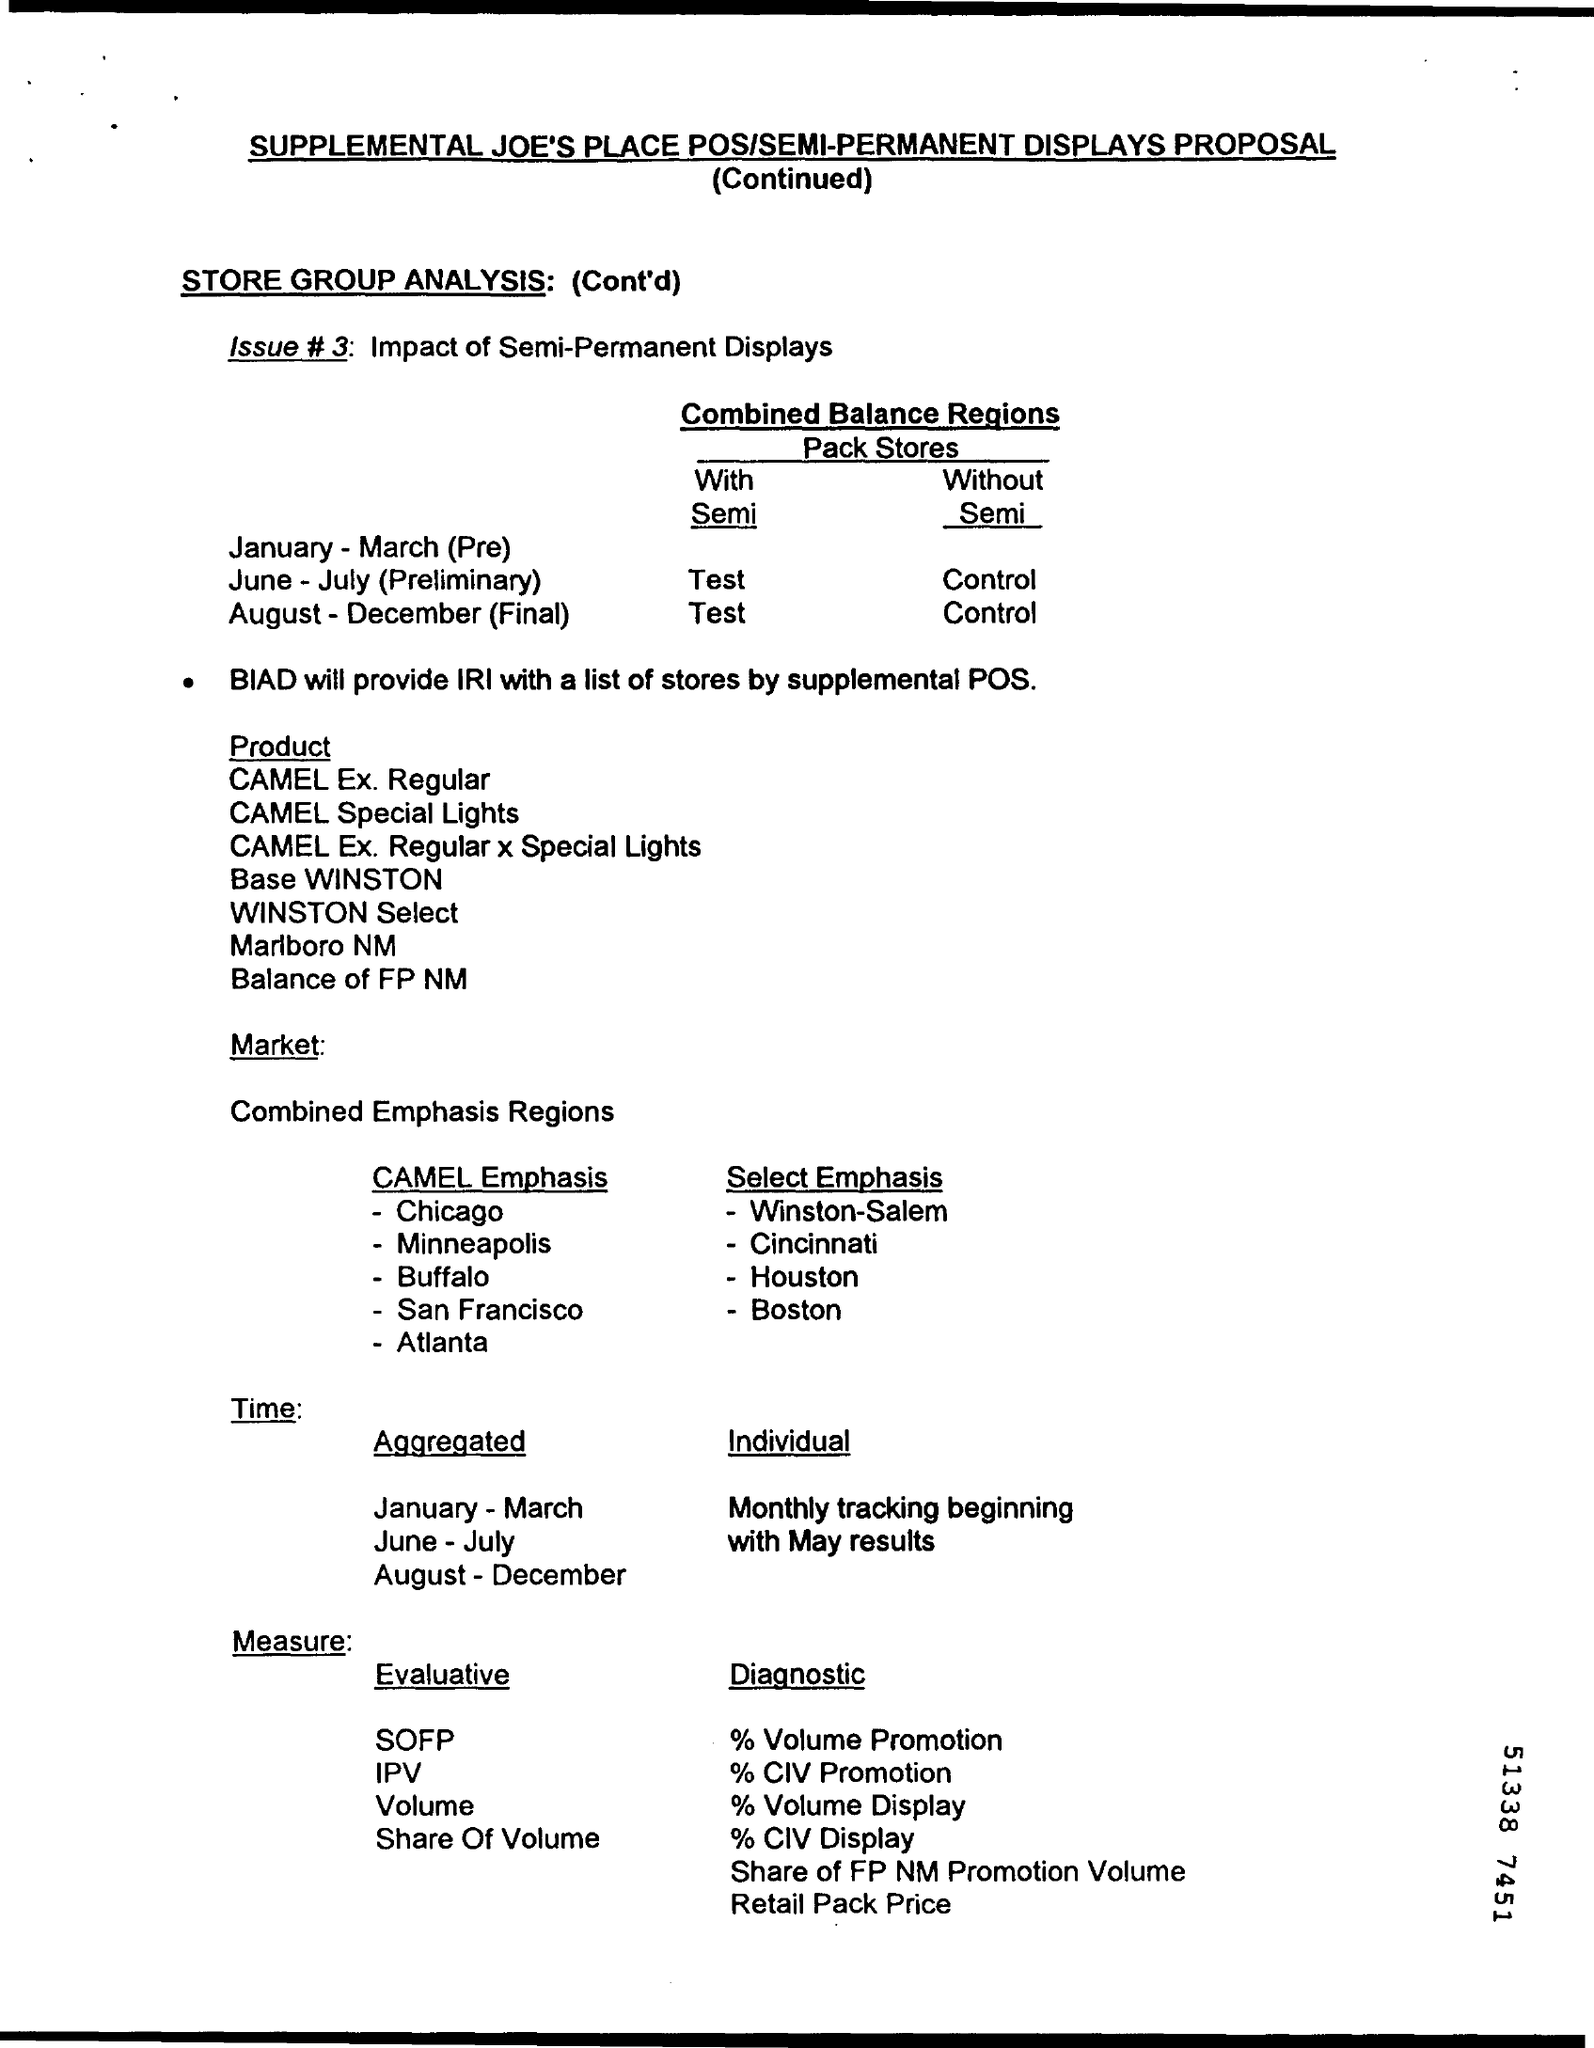What is Issue #3?
Ensure brevity in your answer.  Impact of Semi-Permanent Displays. Who will provide IRI with a list of stores by supplemental POS?
Make the answer very short. BIAD. 